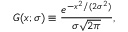<formula> <loc_0><loc_0><loc_500><loc_500>G ( x ; \sigma ) \equiv \frac { e ^ { - x ^ { 2 } / ( 2 \sigma ^ { 2 } ) } } { \sigma { \sqrt { 2 \pi } } } ,</formula> 